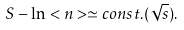Convert formula to latex. <formula><loc_0><loc_0><loc_500><loc_500>S - \ln < n > \simeq c o n s t . ( \sqrt { s } ) .</formula> 